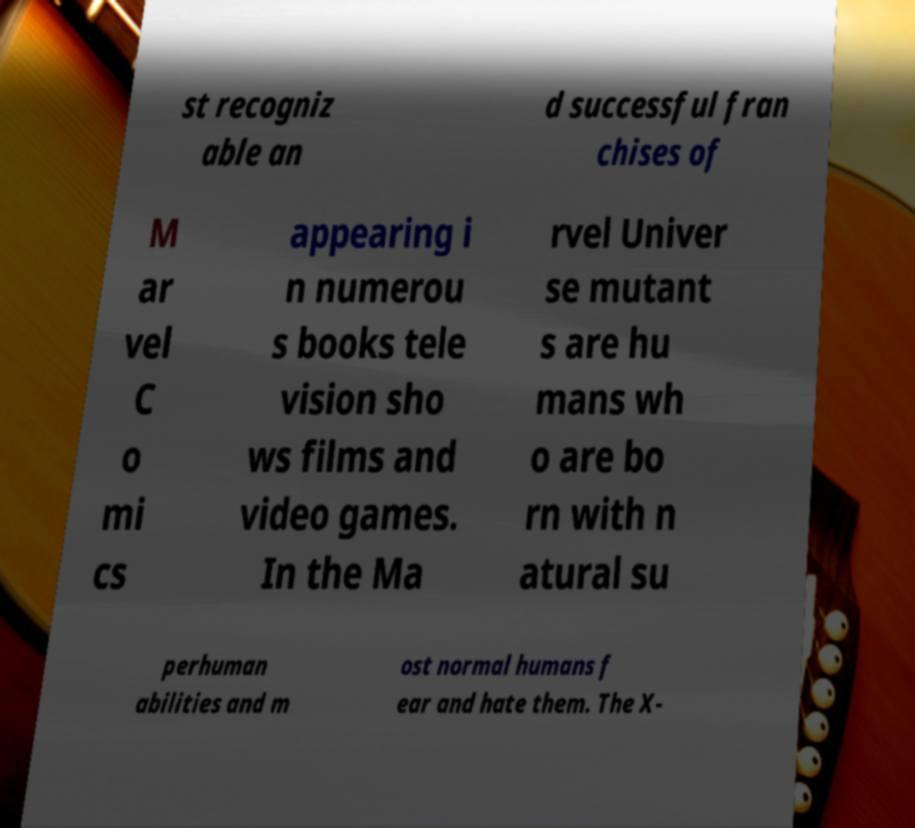I need the written content from this picture converted into text. Can you do that? st recogniz able an d successful fran chises of M ar vel C o mi cs appearing i n numerou s books tele vision sho ws films and video games. In the Ma rvel Univer se mutant s are hu mans wh o are bo rn with n atural su perhuman abilities and m ost normal humans f ear and hate them. The X- 